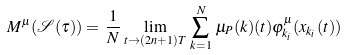<formula> <loc_0><loc_0><loc_500><loc_500>M ^ { \mu } ( \mathcal { S } ( \tau ) ) = \, \frac { 1 } { N } \, \lim _ { t \to ( 2 n + 1 ) T } \, \sum ^ { N } _ { k = 1 } \, \mu _ { P } ( k ) ( t ) \varphi ^ { \mu } _ { k _ { i } } ( x _ { k _ { i } } ( t ) )</formula> 